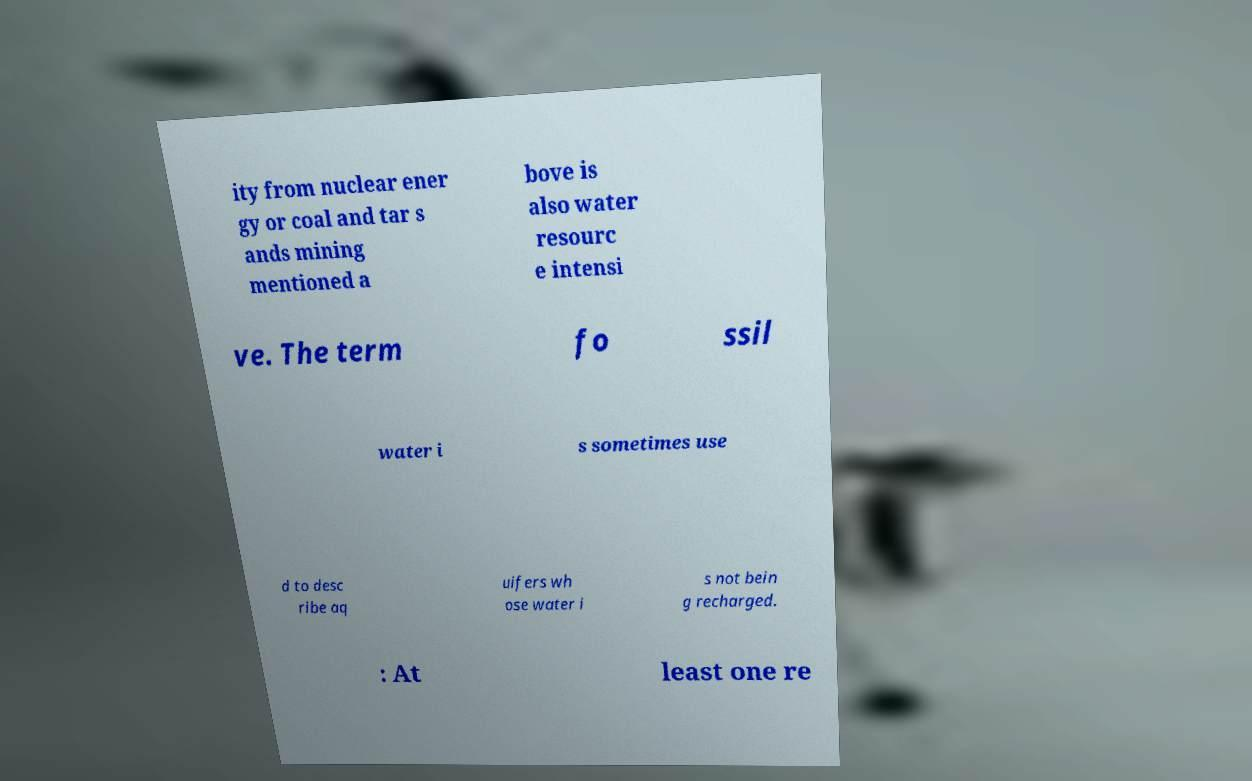Please identify and transcribe the text found in this image. ity from nuclear ener gy or coal and tar s ands mining mentioned a bove is also water resourc e intensi ve. The term fo ssil water i s sometimes use d to desc ribe aq uifers wh ose water i s not bein g recharged. : At least one re 